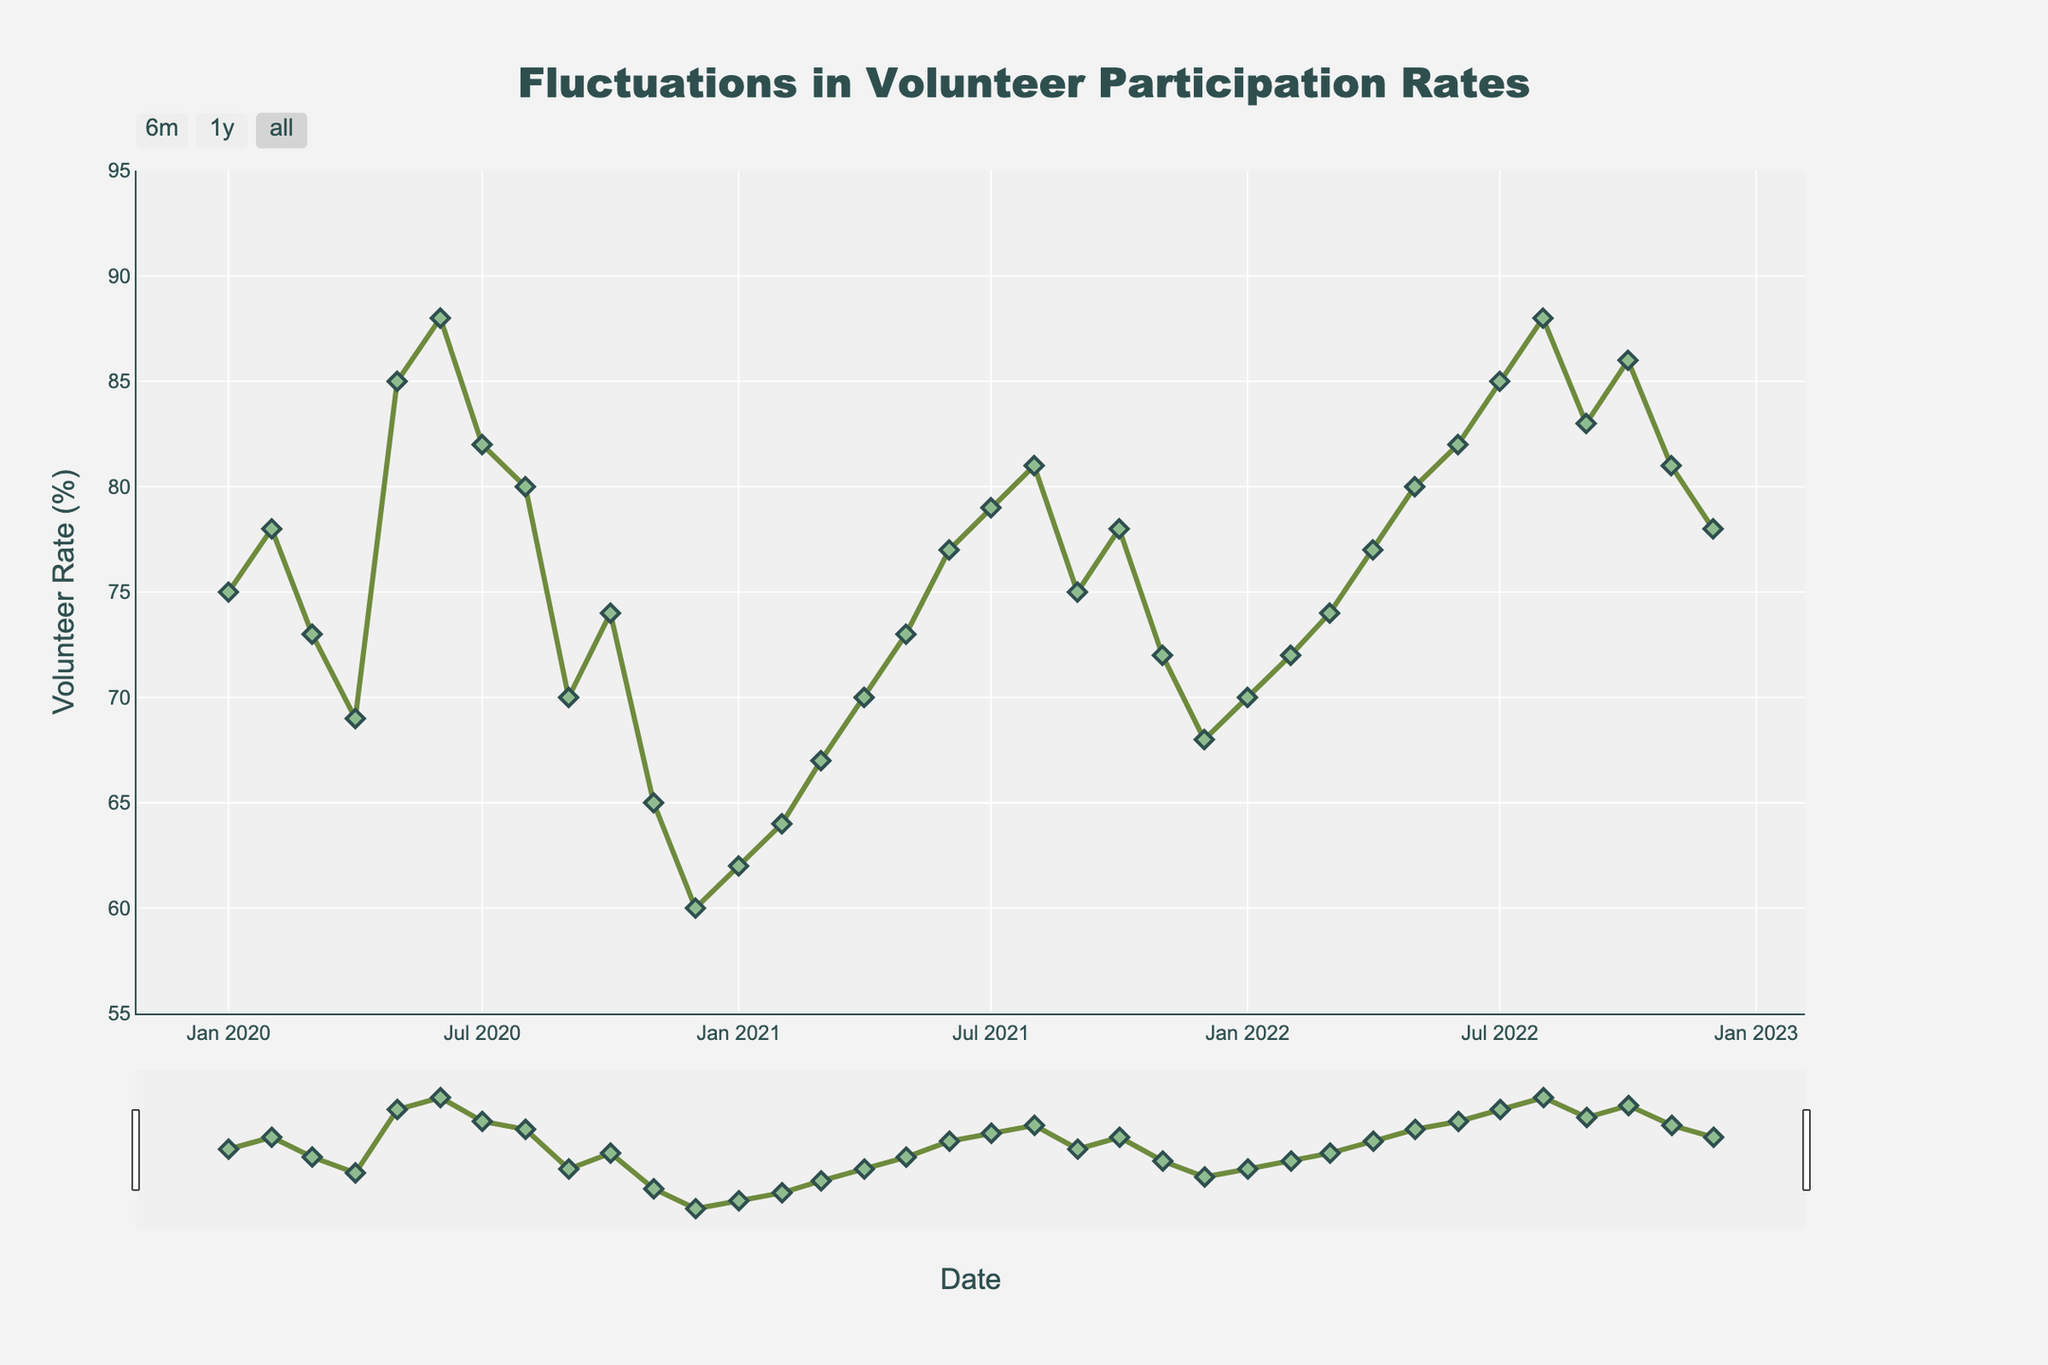What is the title of the plot? The title is typically located at the top center of the plot and provides a summary of what the plot illustrates. Here, the title is "Fluctuations in Volunteer Participation Rates" as it describes the changes in volunteer rates over the provided time period.
Answer: Fluctuations in Volunteer Participation Rates How many data points are plotted on the graph? Data points are marked by symbols on the plot. We can count them directly from January 2020 to December 2022, which covers 12 months per year for 3 years. 12 months x 3 years equals 36 data points.
Answer: 36 What is the color of the line representing the volunteer rate? The color of the line can be identified by looking at the line connecting the data points. Here, the line is described as greenish.
Answer: Greenish In which month and year did the volunteer rate reach its lowest point? To find the lowest point, scan through the plot to locate the data point closest to the bottom. The lowest data point appears in December 2020, with a volunteer rate of 60%.
Answer: December 2020 How does the volunteer rate in June 2020 compare to June 2022? Locate the data points for June 2020 and June 2022 on the plot. June 2020 has a rate of 88%, and June 2022 has 82%. So, the rate is higher in June 2020 compared to June 2022.
Answer: Higher in June 2020 What’s the average volunteer rate for the year 2020? Extract the volunteer rates for each month in 2020, which are 75, 78, 73, 69, 85, 88, 82, 80, 70, 74, 65, 60. Sum these values (75 + 78 + 73 + 69 + 85 + 88 + 82 + 80 + 70 + 74 + 65 + 60 = 899) and then divide by 12 (899 / 12 = 74.91).
Answer: 74.91 Which year experienced the most significant increase in volunteer rate from January to December? For each year, compare the January value to the December value. Calculate the changes: 
2020: 75 - 60 = -15
2021: 62 - 68 = 6
2022: 70 - 78 = 8
The most significant increase occurred in 2022.
Answer: 2022 When did the volunteer rate first exceed 80% after January 2020? Scan the data points starting from January 2020 until you find the first value above 80%. The first occurrence where the rate exceeds 80% is in June 2020.
Answer: June 2020 What is the overall trend of the volunteer rate from January 2020 to December 2022? Observe the pattern of the plotted line from the start to the end date. It shows fluctuations but generally depicts a trend of recovery after a drop in 2020, ending slightly higher than it started in January 2020.
Answer: Recovery trend How many times does the volunteer rate dip below 70%? Count the number of instances where the points fall below the 70% line:
April 2020 (69), September 2020 (70), October 2020 (74), November 2020 (65), December 2020 (60), January 2021 (62), February 2021 (64), March 2021 (67), November 2021 (72), December 2021 (68).
Total count: 9 times.
Answer: 9 